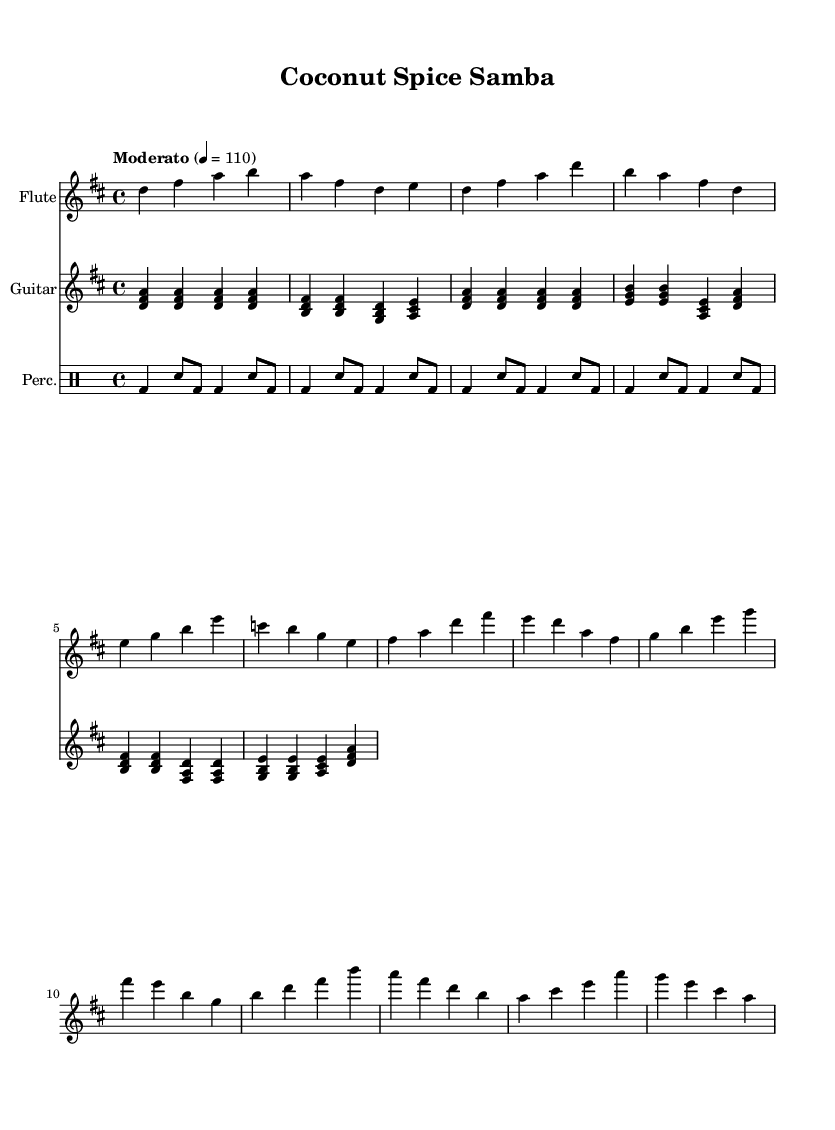What is the key signature of this music? The key signature is indicated by the sharps or flats at the beginning of the staff. In this case, the music is in D major, which has two sharps (F# and C#).
Answer: D major What is the time signature of this piece? The time signature is found right after the key signature at the beginning of the sheet music. The notation shows a 4/4, which indicates four beats per measure with a quarter note receiving one beat.
Answer: 4/4 What is the tempo marking of this piece? The tempo marking is provided at the beginning and indicates the speed of the piece. Here, "Moderato" followed by a metronome marking of 110 indicates a moderate speed.
Answer: Moderato How many measures are in the flute part? To find the number of measures, we can count the distinct groups of vertical lines (bars) that indicate the end of each measure in the flute part. There are eight measures in total for the flute.
Answer: 8 Which instruments are featured in this sheet music? The instruments are indicated at the beginning of each staff. The sheet music features flute, guitar, and percussion.
Answer: Flute, Guitar, Percussion How many different chord shapes are used in the guitar part? By analyzing the guitar part, we can see the chords played within the measures. There are four distinct chord shapes throughout the guitar part (D, B, G, A).
Answer: 4 What type of rhythm pattern is primarily used in the percussion section? The percussion section consists of bass drum and snare drum patterns. The rhythm pattern primarily follows a repetitive 4/4 pattern alternating between bass and snare in a basic samba style.
Answer: Samba 